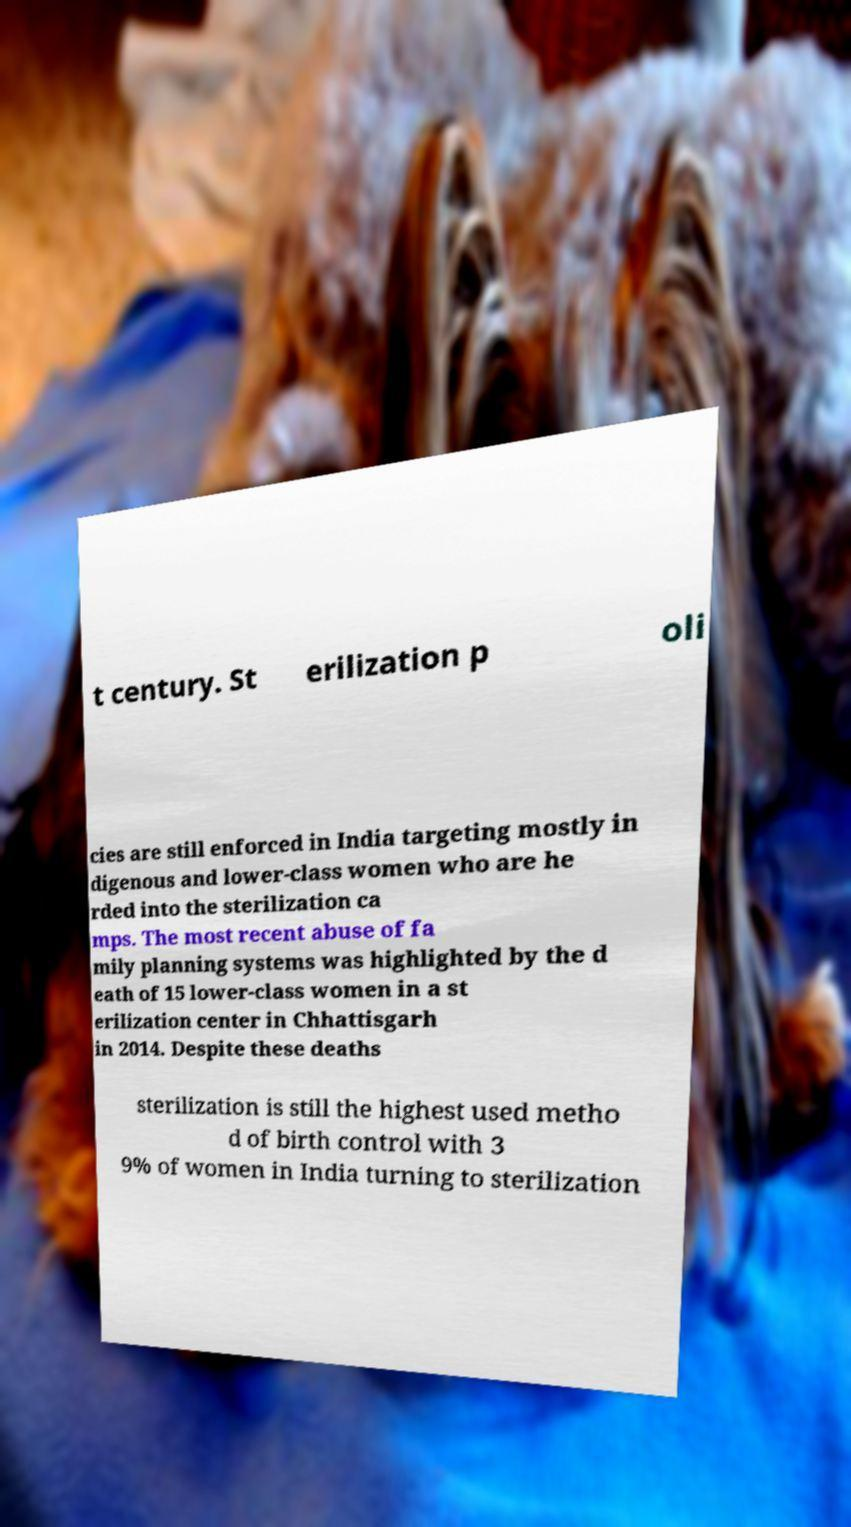Please identify and transcribe the text found in this image. t century. St erilization p oli cies are still enforced in India targeting mostly in digenous and lower-class women who are he rded into the sterilization ca mps. The most recent abuse of fa mily planning systems was highlighted by the d eath of 15 lower-class women in a st erilization center in Chhattisgarh in 2014. Despite these deaths sterilization is still the highest used metho d of birth control with 3 9% of women in India turning to sterilization 